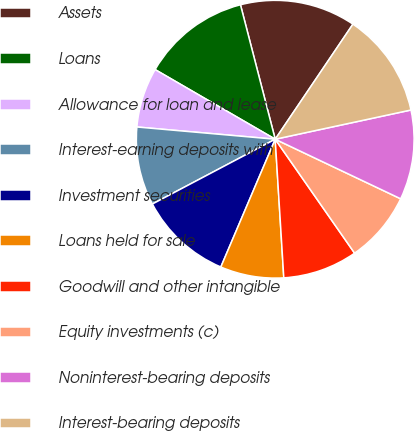Convert chart to OTSL. <chart><loc_0><loc_0><loc_500><loc_500><pie_chart><fcel>Assets<fcel>Loans<fcel>Allowance for loan and lease<fcel>Interest-earning deposits with<fcel>Investment securities<fcel>Loans held for sale<fcel>Goodwill and other intangible<fcel>Equity investments (c)<fcel>Noninterest-bearing deposits<fcel>Interest-bearing deposits<nl><fcel>13.48%<fcel>12.61%<fcel>6.96%<fcel>9.13%<fcel>10.87%<fcel>7.39%<fcel>8.7%<fcel>8.26%<fcel>10.43%<fcel>12.17%<nl></chart> 